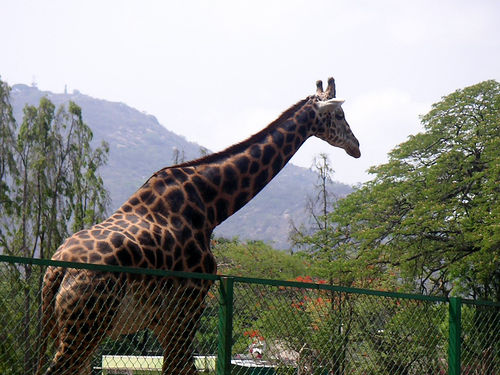What is the giraffe doing in the image? The giraffe appears to be in a calm and relaxed state, possibly contemplating its surroundings or waiting for something. 